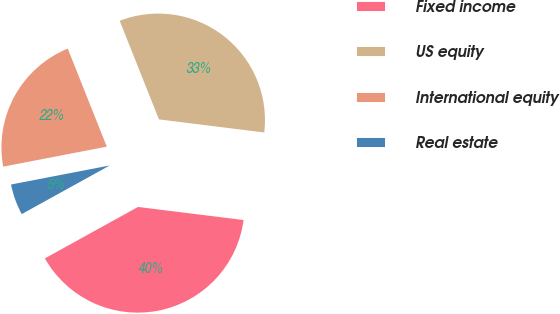Convert chart. <chart><loc_0><loc_0><loc_500><loc_500><pie_chart><fcel>Fixed income<fcel>US equity<fcel>International equity<fcel>Real estate<nl><fcel>40.0%<fcel>33.0%<fcel>22.0%<fcel>5.0%<nl></chart> 